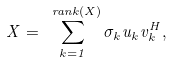<formula> <loc_0><loc_0><loc_500><loc_500>X = \sum _ { k = 1 } ^ { \ r a n k ( X ) } \sigma _ { k } u _ { k } v _ { k } ^ { H } ,</formula> 